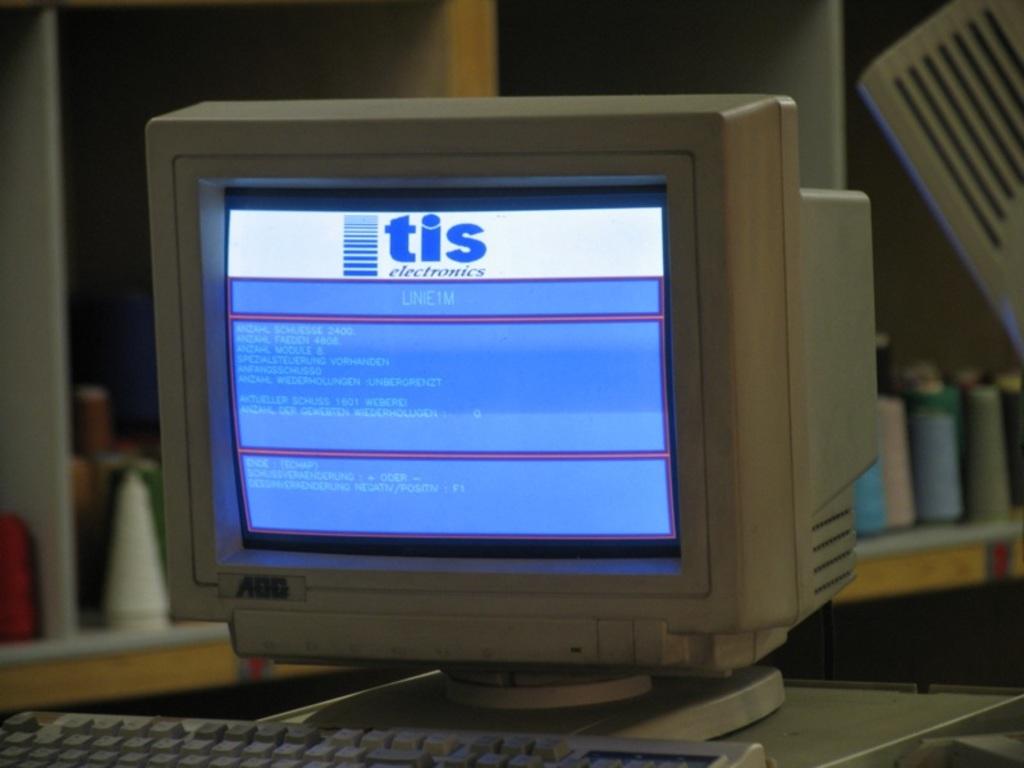What is the top text on the computer screen?
Provide a short and direct response. Tis. What is the first word on the blue background?
Offer a terse response. Line1m. 